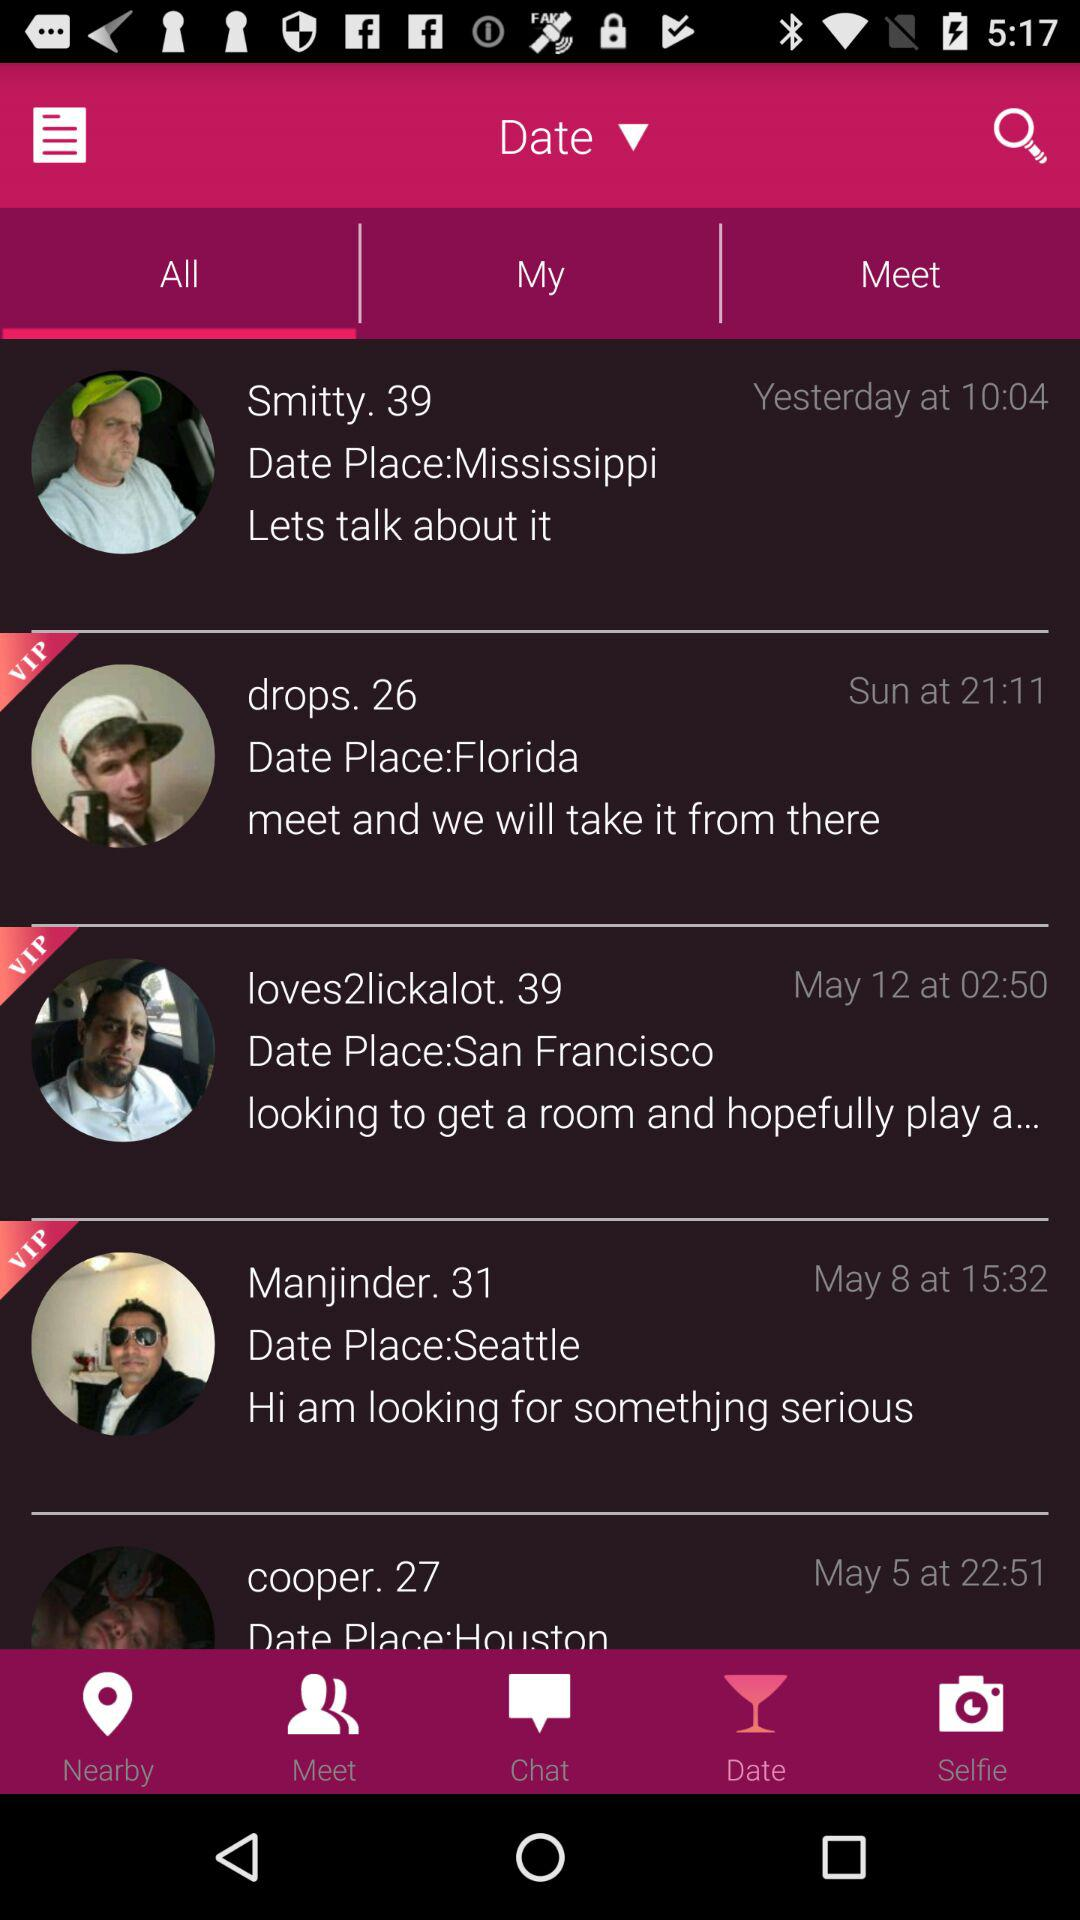What is the age of Smitty? Smitty is 39 years old. 